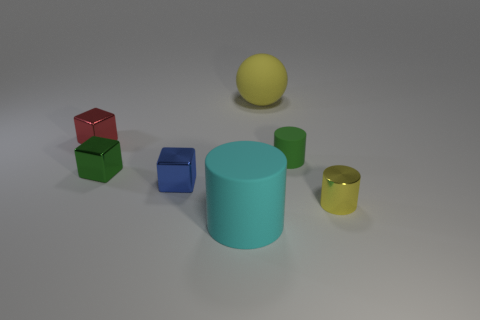Are there any large matte spheres that have the same color as the small metallic cylinder?
Ensure brevity in your answer.  Yes. What is the size of the object that is the same color as the tiny rubber cylinder?
Your answer should be very brief. Small. Is there anything else that has the same shape as the blue metal thing?
Offer a very short reply. Yes. Are the yellow cylinder and the big yellow thing behind the yellow metallic cylinder made of the same material?
Ensure brevity in your answer.  No. The large matte thing that is right of the large thing in front of the metal object on the right side of the green cylinder is what color?
Your response must be concise. Yellow. There is a green shiny object that is the same size as the blue thing; what shape is it?
Your response must be concise. Cube. Are there any other things that are the same size as the blue block?
Your response must be concise. Yes. There is a cyan cylinder that is right of the red cube; is its size the same as the rubber cylinder that is to the right of the sphere?
Offer a very short reply. No. What is the size of the yellow object that is behind the green block?
Make the answer very short. Large. There is a cylinder that is the same color as the big sphere; what material is it?
Your answer should be very brief. Metal. 